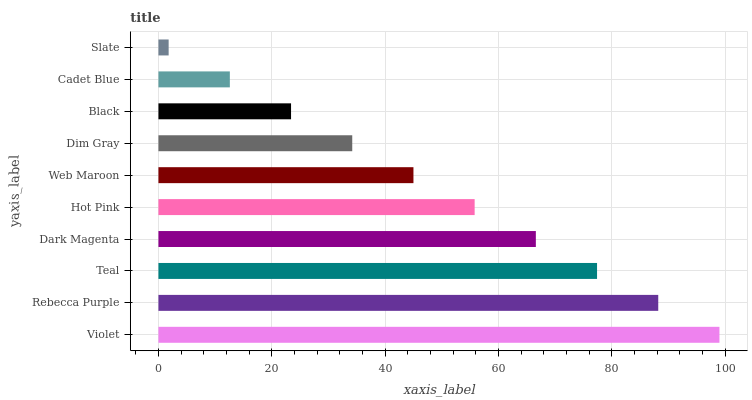Is Slate the minimum?
Answer yes or no. Yes. Is Violet the maximum?
Answer yes or no. Yes. Is Rebecca Purple the minimum?
Answer yes or no. No. Is Rebecca Purple the maximum?
Answer yes or no. No. Is Violet greater than Rebecca Purple?
Answer yes or no. Yes. Is Rebecca Purple less than Violet?
Answer yes or no. Yes. Is Rebecca Purple greater than Violet?
Answer yes or no. No. Is Violet less than Rebecca Purple?
Answer yes or no. No. Is Hot Pink the high median?
Answer yes or no. Yes. Is Web Maroon the low median?
Answer yes or no. Yes. Is Black the high median?
Answer yes or no. No. Is Dark Magenta the low median?
Answer yes or no. No. 